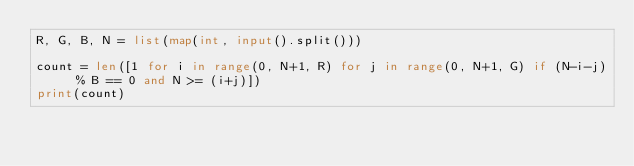<code> <loc_0><loc_0><loc_500><loc_500><_Python_>R, G, B, N = list(map(int, input().split()))
 
count = len([1 for i in range(0, N+1, R) for j in range(0, N+1, G) if (N-i-j) % B == 0 and N >= (i+j)])
print(count)</code> 